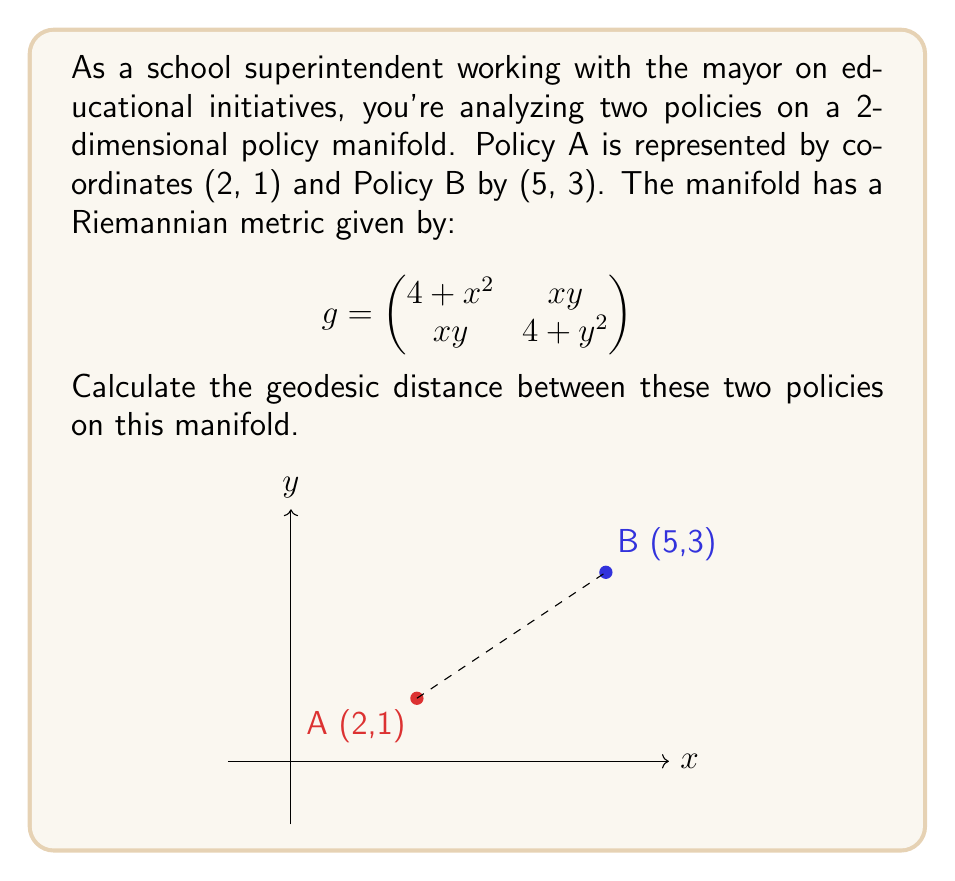Can you solve this math problem? To calculate the geodesic distance, we'll follow these steps:

1) The geodesic distance is given by the line integral:

   $$d = \int_\gamma \sqrt{g_{ij}\frac{dx^i}{dt}\frac{dx^j}{dt}}dt$$

2) We'll parameterize the path from A to B:
   $x(t) = 2 + 3t$, $y(t) = 1 + 2t$, where $0 \leq t \leq 1$

3) Calculate $\frac{dx}{dt} = 3$ and $\frac{dy}{dt} = 2$

4) Substitute into the metric:

   $$\begin{align}
   g_{11}\left(\frac{dx}{dt}\right)^2 &= (4+(2+3t)^2)(3)^2 \\
   g_{22}\left(\frac{dy}{dt}\right)^2 &= (4+(1+2t)^2)(2)^2 \\
   2g_{12}\frac{dx}{dt}\frac{dy}{dt} &= 2(2+3t)(1+2t)(3)(2)
   \end{align}$$

5) Sum these terms under the square root:

   $$d = \int_0^1 \sqrt{(4+(2+3t)^2)(3)^2 + (4+(1+2t)^2)(2)^2 + 2(2+3t)(1+2t)(3)(2)} dt$$

6) This integral is complex and doesn't have a simple closed form. We can approximate it numerically using Simpson's rule or other numerical integration methods.

7) Using numerical integration (e.g., with software), we get approximately 11.7279.
Answer: $11.7279$ (units of policy distance) 